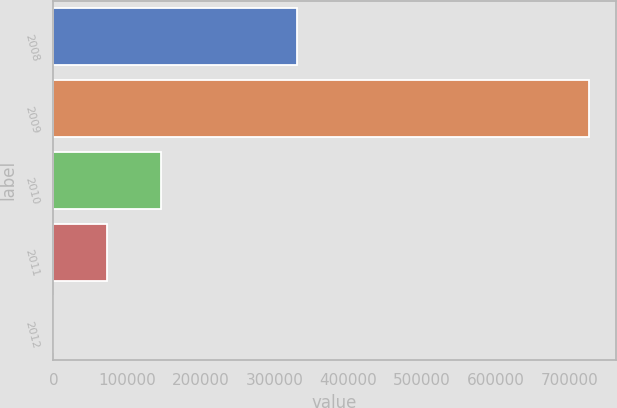Convert chart to OTSL. <chart><loc_0><loc_0><loc_500><loc_500><bar_chart><fcel>2008<fcel>2009<fcel>2010<fcel>2011<fcel>2012<nl><fcel>331103<fcel>726692<fcel>145348<fcel>72680<fcel>12<nl></chart> 